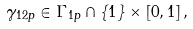Convert formula to latex. <formula><loc_0><loc_0><loc_500><loc_500>\gamma _ { 1 2 p } \in \Gamma _ { 1 p } \cap \left \{ 1 \right \} \times \left [ 0 , 1 \right ] ,</formula> 